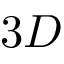<formula> <loc_0><loc_0><loc_500><loc_500>3 D</formula> 